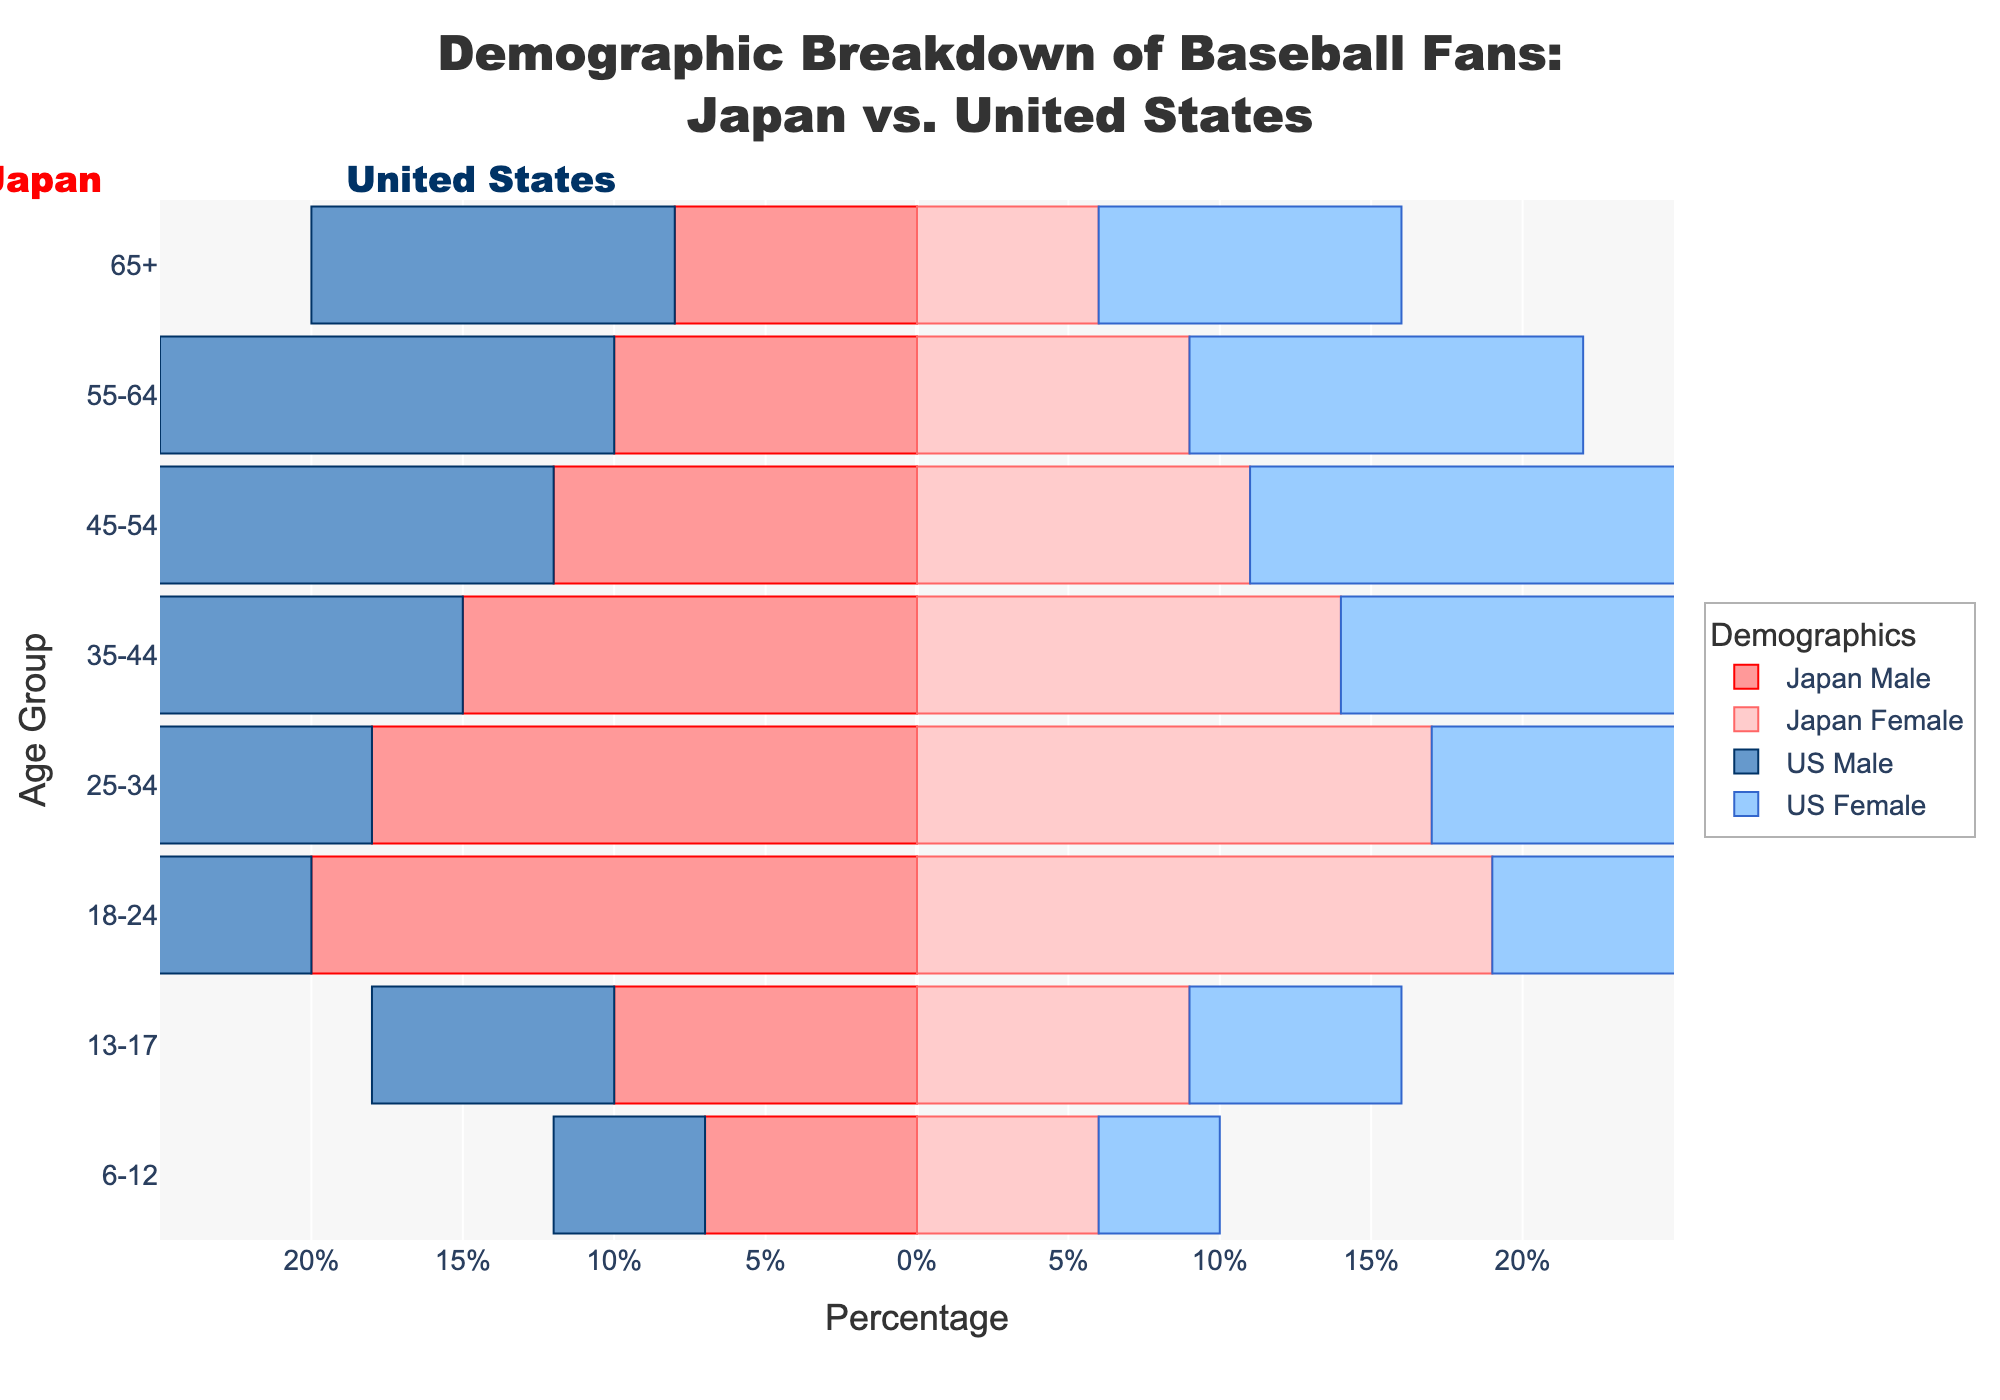What is the title of the figure? The title of the figure is located at the top of the plot and should be clearly visible. The title helps to understand the primary focus of the plot.
Answer: Demographic Breakdown of Baseball Fans: Japan vs. United States Which age group has the highest percentage of baseball fans in both Japan and the United States? Identify the age group with the maximum value on both sides of the pyramid for each country. The comparison will reveal the age group with the highest percentage.
Answer: 18-24 How does the percentage of Japan Male fans age 18-24 compare to US Male fans of the same age group? Look at the length of the bars representing Japan Male and US Male for the age group 18-24. Since the bars are mirrored, the one extending further to the left or right indicates a higher percentage.
Answer: The percentage of Japan Male fans age 18-24 is higher than US Male fans Which gender among US fans has a higher percentage in the 55-64 age group? Compare the lengths of the bars for US Male and US Female in the 55-64 age group. The longer bar indicates a higher percentage.
Answer: US Male What is the percentage difference between the youngest age group (6-12) of Japan Male and US Male fans? Note the percentages for Japan Male and US Male in the 6-12 age group. Calculate the difference by subtracting the smaller percentage from the larger one.
Answer: 2% Which country has a higher percentage of female fans in the 45-54 age group? Compare the lengths of the bars for Japan Female and US Female in the 45-54 age group. The longer bar indicates the higher percentage.
Answer: United States How does the percentage of female fans in the 25-34 age group compare between Japan and the United States? Look at the lengths of the bars representing Japan Female and US Female for the 25-34 age group. The longer bar indicates the higher percentage.
Answer: Japan's percentage is higher Which country's younger demographic (under 18) has a higher overall percentage of fans? Sum the percentages of the age groups 6-12 and 13-17 for both Japan and the United States. Compare the totals to determine which country has a higher overall percentage of younger fans.
Answer: Japan Do older age groups (55-64 and 65+) in the United States have a higher percentage of fans compared to Japan? Compare the summed lengths of the bars for US fans and Japanese fans in the 55-64 and 65+ age groups to see which country has a higher combined percentage.
Answer: Yes 